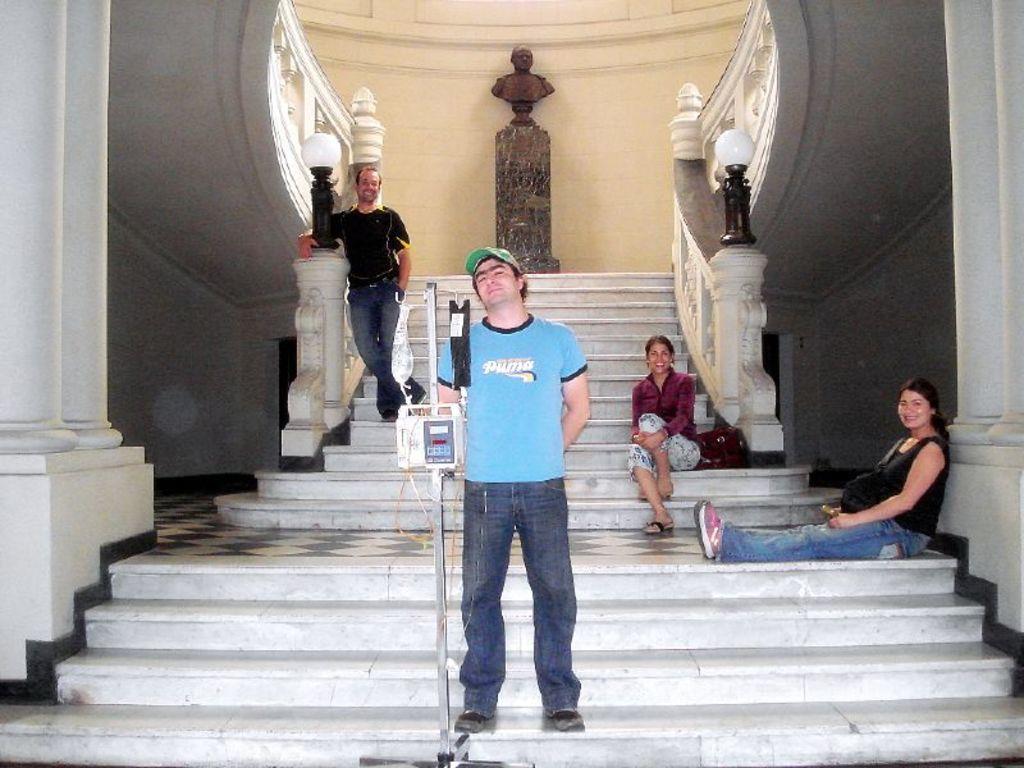Could you give a brief overview of what you see in this image? Here in this picture, in the middle we can see two men standing on the steps and we can see two women sitting over there and all of them are smiling and the man in the front is having an equipment on a stand in front of him and we can see he is wearing cap and behind them we can see a statue present an we can also see lamp posts present on the side railing walls. 